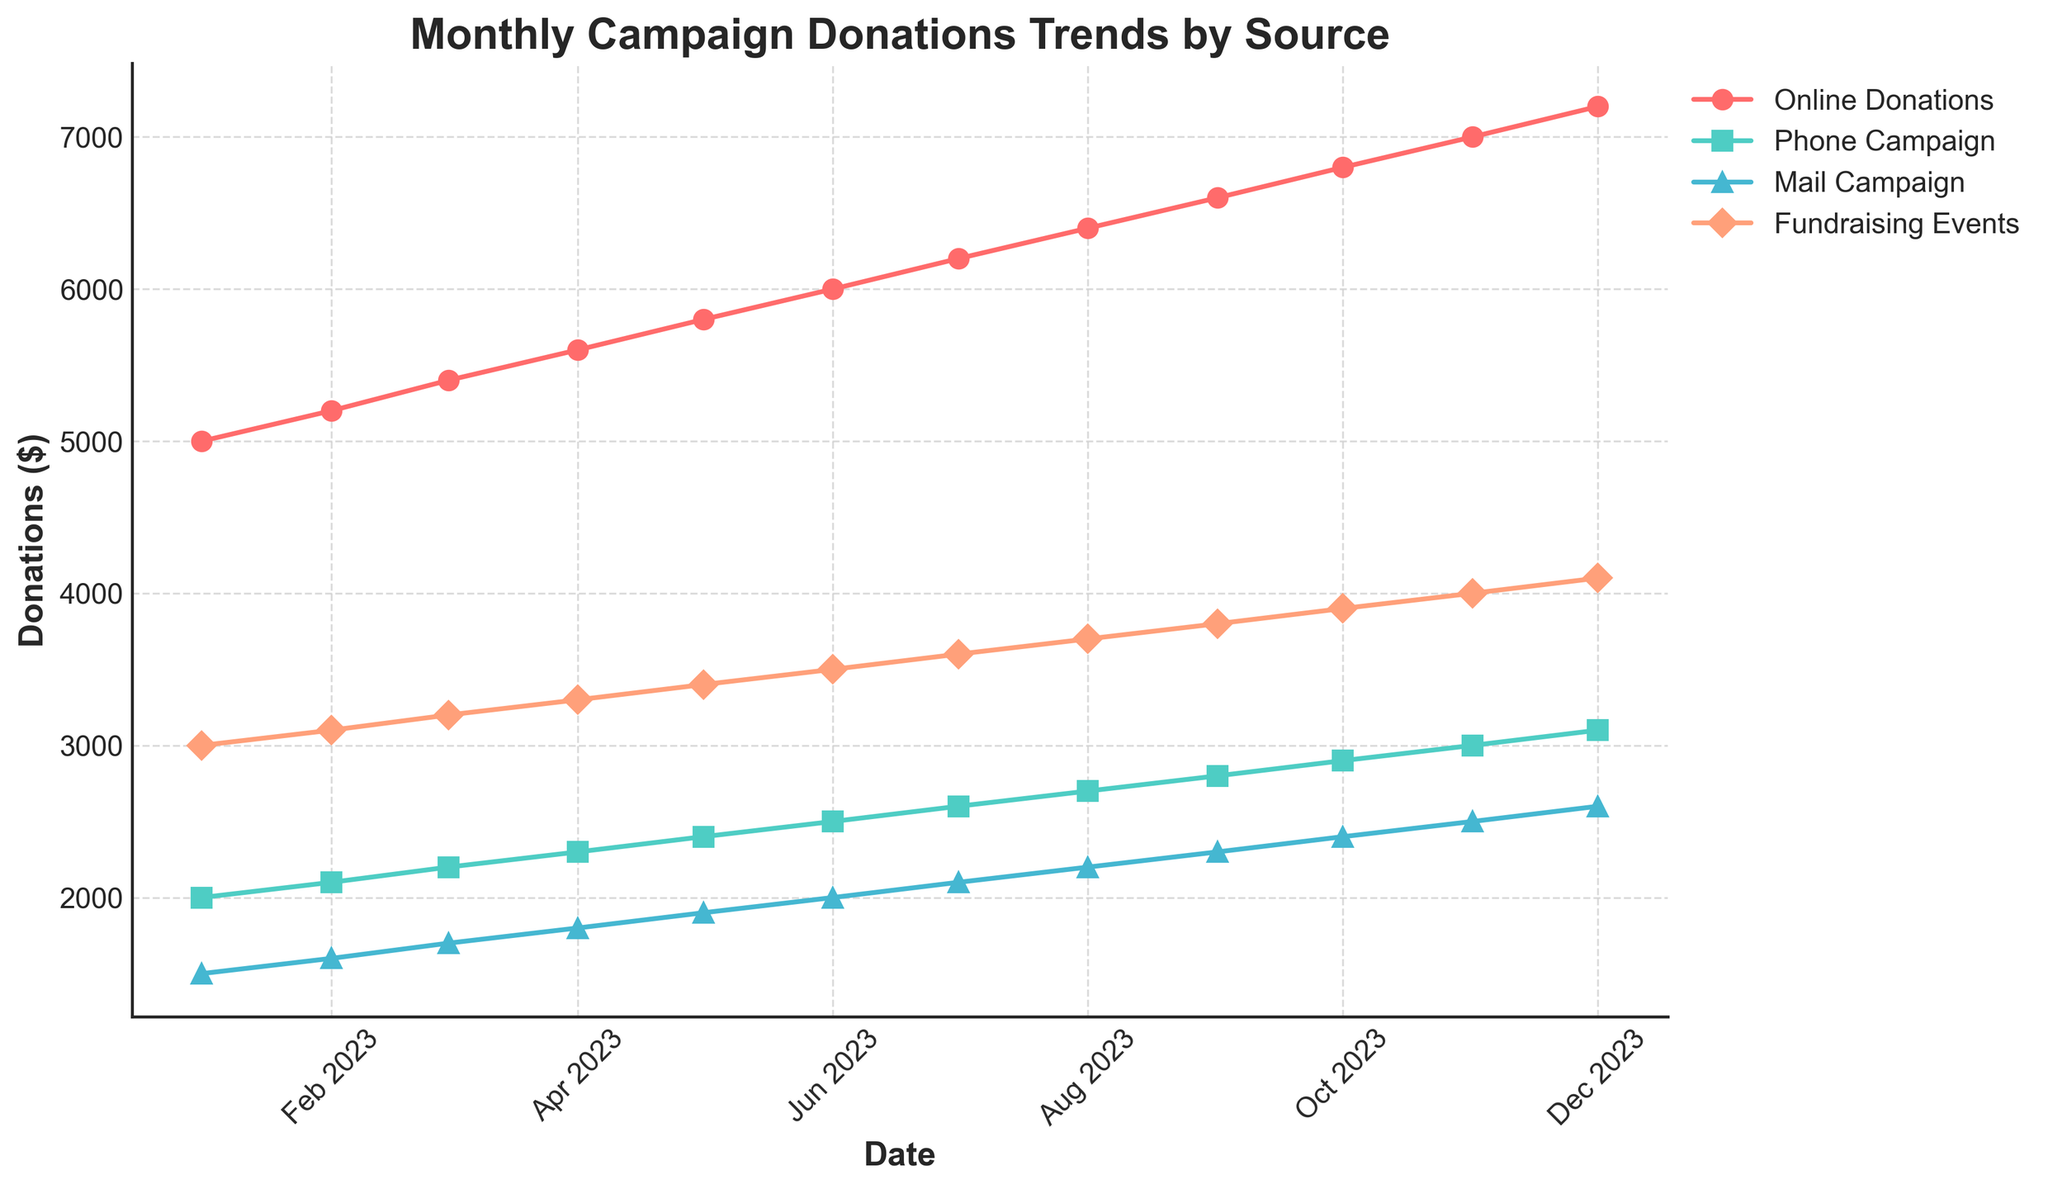What is the title of the figure? The title of the figure is typically the largest text, situated at the top of the plot. It serves to give an overview of what the data represents. In this case, it is positioned at the center above the plotting area.
Answer: Monthly Campaign Donations Trends by Source On which date did Online Donations reach $7000? To find this, look at the Online Donations series (marked by 'o' markers) on the plot and find the point where the value reaches $7000. Then trace vertically down to the corresponding date on the x-axis.
Answer: November 2023 Which donation source had the highest value in December 2023? Examine the values for each donation source in December 2023. Look at the highest point among all plot lines for that specific month.
Answer: Online Donations What is the overall trend for Phone Campaign donations throughout the year? Observe the Phone Campaign line (marked by 's' markers). Trace from January to December to see if the general direction is upward or downward.
Answer: Increasing By how much did Mail Campaign donations increase from January to December? Check the value for Mail Campaign donations in January and December. Subtract the January value from the December value.
Answer: 1100 USD Which two months saw the highest increase in Fundraising Events donations? Look at the Fundraising Events line and identify the two points with the steepest increase between consecutive months.
Answer: January to February and December to January If we compare the growth of Online Donations and Phone Campaigns, which grew more from July to October? Check the values for both Online Donations and Phone Campaigns in July and October. Calculate the difference for both, then compare them.
Answer: Online Donations What is the average amount of Mail Campaign donations over the year? Add up all the monthly values for Mail Campaign donations and divide by 12 (one for each month). This results in: (1500+1600+1700+1800+1900+2000+2100+2200+2300+2400+2500+2600)/12.
Answer: 2050 USD In which month did Phone Campaign donations reach $2800? Find the point on the Phone Campaign plot line where the value is $2800 and trace it vertically to the x-axis to identify the month.
Answer: September 2023 How many different donation sources are represented in the plot? Count the number of distinct lines plotted, with each line representing a different donation source. The legend also lists the sources.
Answer: 4 